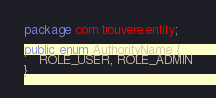Convert code to text. <code><loc_0><loc_0><loc_500><loc_500><_Java_>package com.trouvere.entity;

public enum AuthorityName {
    ROLE_USER, ROLE_ADMIN
}</code> 